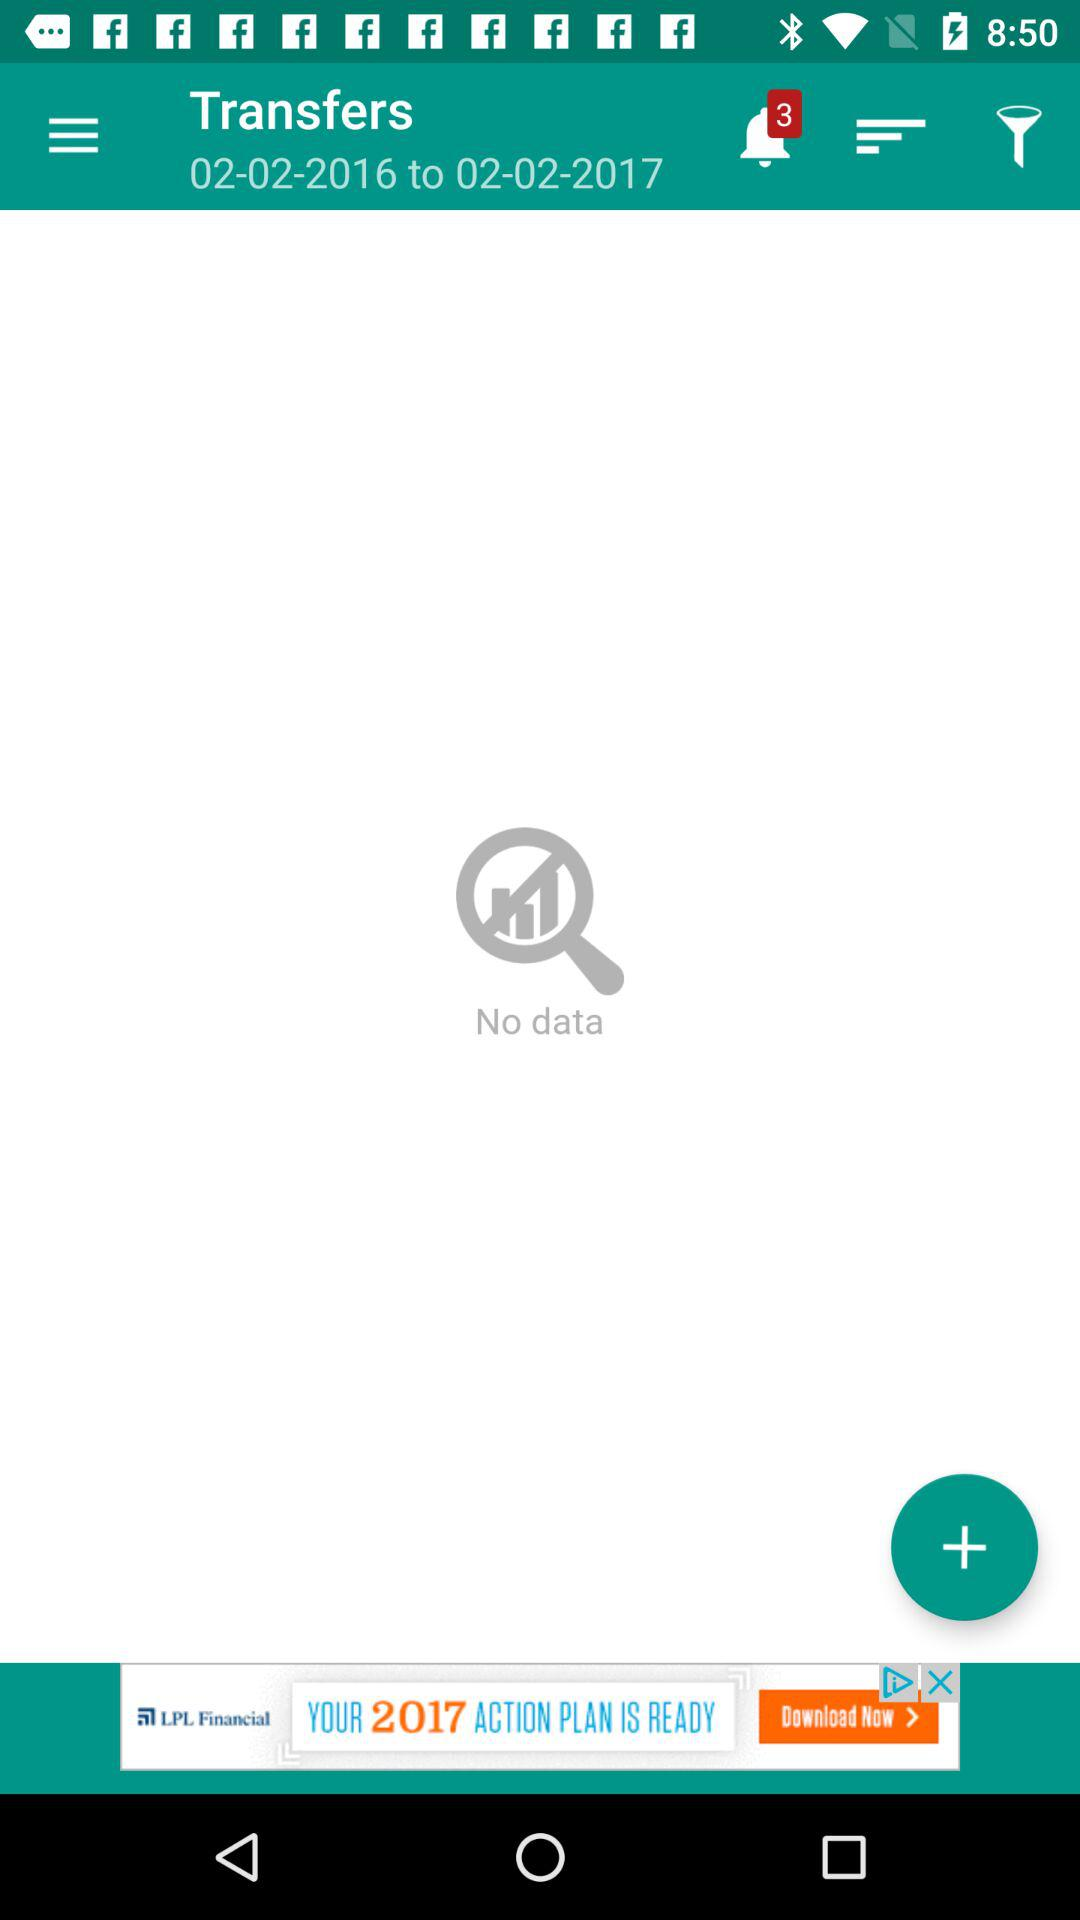What is the "Transfers" date showing? It is showing 02-02-2016 to 02-02-2017. 